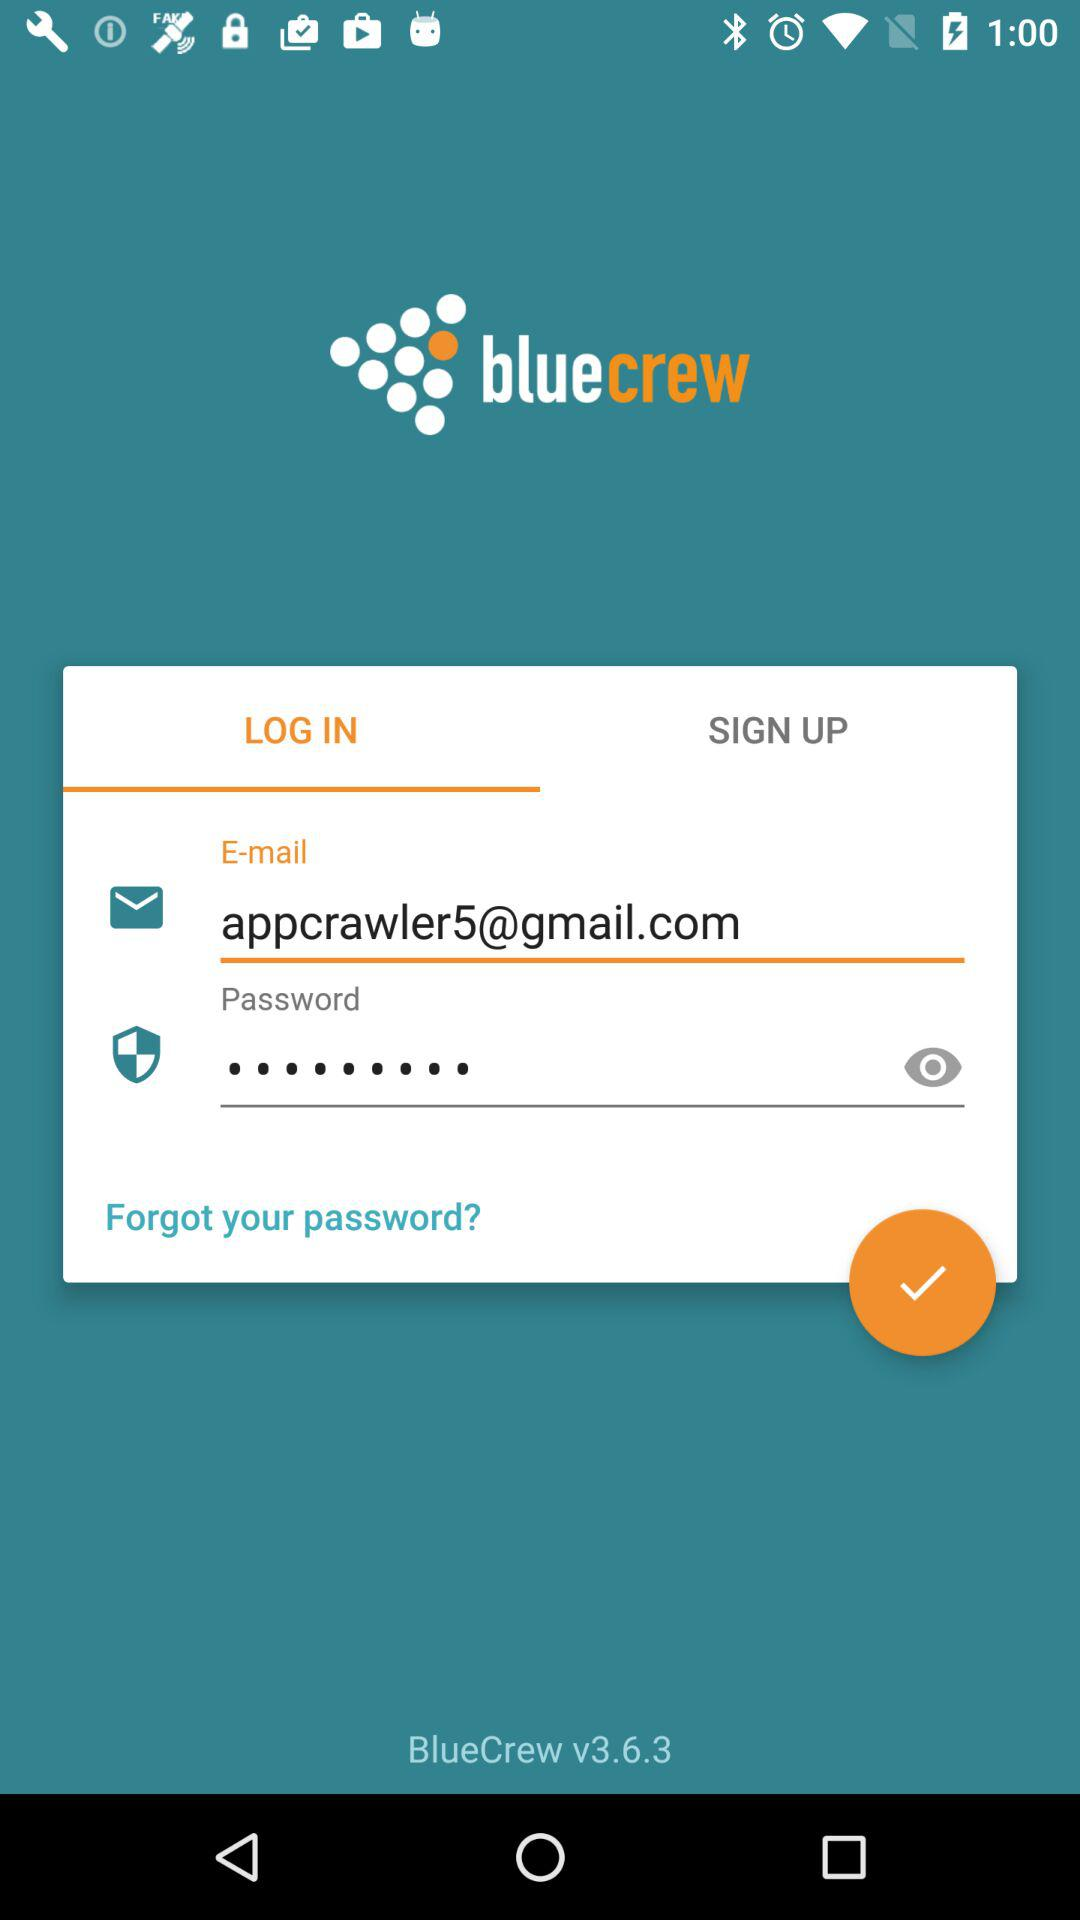What is the given gmail address? The gmail address is appcrawler5@gmail.com. 